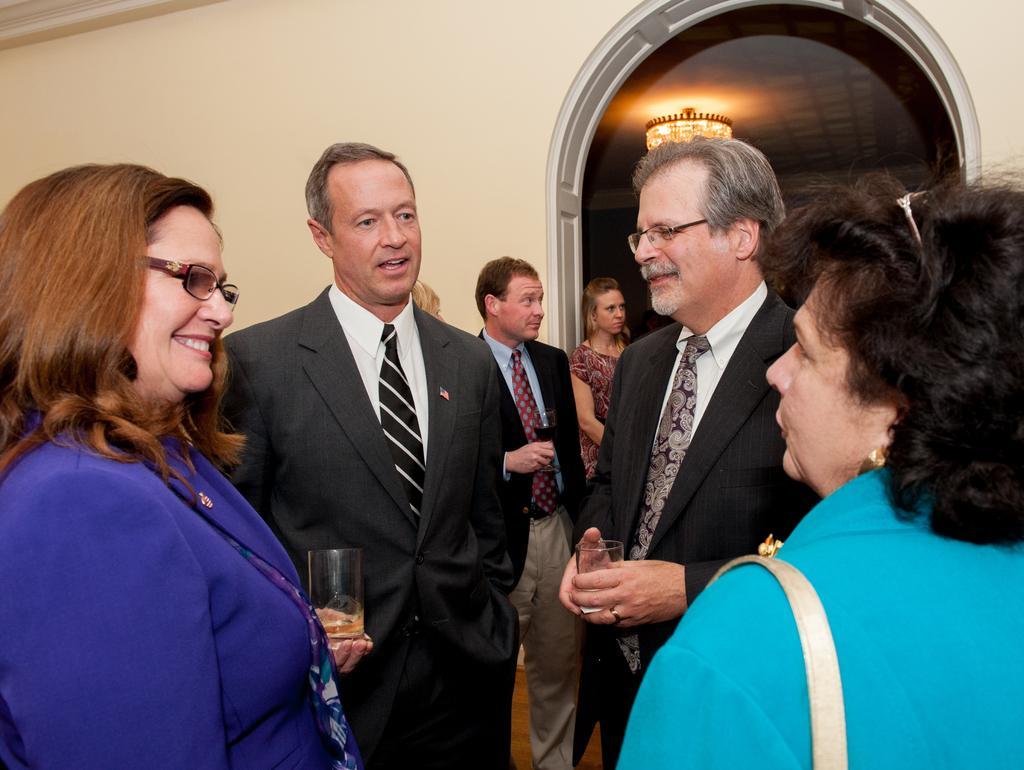Please provide a concise description of this image. In this image we can see a few people standing, among them some people are holding the glasses, in the background it looks like a building, at the top of the roof we can see a lamp. 